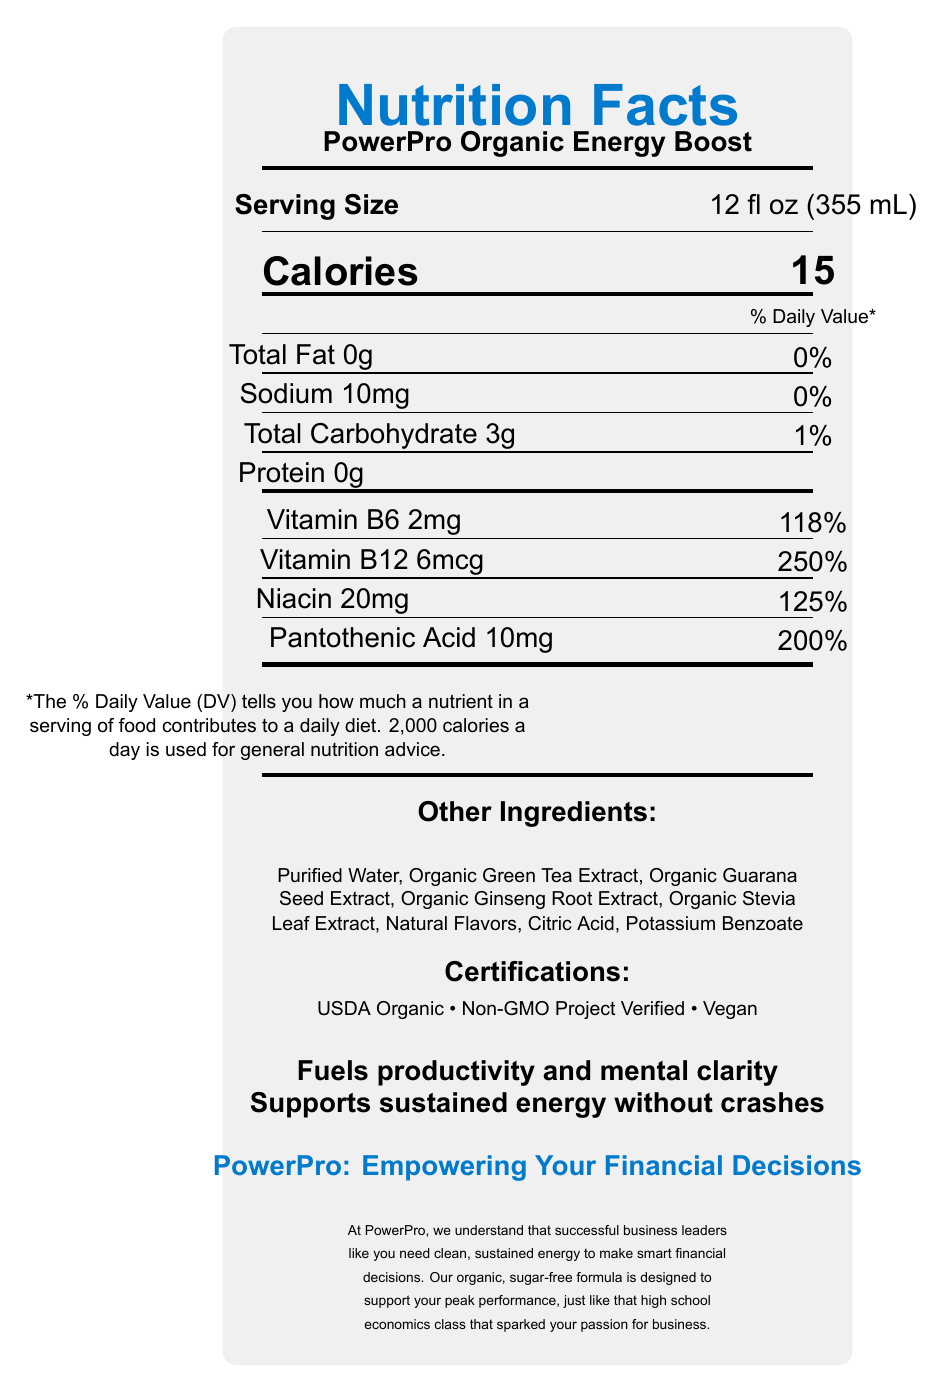what is the serving size of PowerPro Organic Energy Boost? The serving size is listed towards the top of the document under the heading "Serving Size".
Answer: 12 fl oz (355 mL) what is the amount of total fat per serving? The amount of total fat is mentioned under the section for nutrients, specifically stating "Total Fat 0g".
Answer: 0g How many calories are there in one serving of PowerPro Organic Energy Boost? The calorie content is displayed prominently in large font under the heading "Calories".
Answer: 15 What is the daily value percentage for Vitamin B12? The daily value percentage for Vitamin B12 is listed as 250%, found under the vitamins and minerals section.
Answer: 250% List any certifications mentioned for PowerPro Organic Energy Boost. The certifications are listed in the section titled "Certifications" towards the bottom of the document.
Answer: USDA Organic, Non-GMO Project Verified, Vegan Which ingredient in PowerPro Organic Energy Boost contributes to its caffeine content? This is inferred from common knowledge, as Guarana is known to contain caffeine, and it is listed in the ingredients section.
Answer: Organic Guarana Seed Extract What is the branding tagline at the bottom of the document? The tagline is found towards the bottom in a different color text, setting it apart from the rest of the document.
Answer: PowerPro: Empowering Your Financial Decisions How much sodium is there in one serving? The sodium content per serving is listed under the nutrients as "Sodium 10mg".
Answer: 10mg Is PowerPro Organic Energy Boost sugar-free? The product is labeled as sugar-free based on the marketing claims provided.
Answer: Yes What are the potential allergens mentioned in the document? The allergen information stated that the product is produced in a facility that also processes soy and tree nuts.
Answer: Soy and tree nuts What is the main idea of the document? The document presents nutritional details and appeals to health-conscious corporate leaders by emphasizing clean energy and mental clarity.
Answer: The document presents the Nutrition Facts Label for PowerPro Organic Energy Boost, highlighting its low-calorie content, high percentages of B vitamins, caffeine content, organic ingredients, certifications, and marketing claims aimed at business leaders seeking sustained energy and mental clarity without crashes. Identify how many elements are listed under "Other Ingredients". A. 5 B. 7 C. 8 D. 10 The document lists 8 ingredients under "Other Ingredients": Purified Water, Organic Green Tea Extract, Organic Guarana Seed Extract, Organic Ginseng Root Extract, Organic Stevia Leaf Extract, Natural Flavors, Citric Acid, and Potassium Benzoate.
Answer: C What percentage of daily value do the total carbohydrates in one serving contribute? A. 0% B. 1% C. 5% D. 10% The total carbohydrates contribute 1% to the daily value, as listed in the nutrient section.
Answer: B Does the product contain any artificial sweeteners? The document explicitly states in the marketing claims that there are no artificial sweeteners.
Answer: No What is the approximate caffeine content as compared to an average cup of coffee? The document lists the caffeine content but does not provide a comparison to the caffeine content of an average cup of coffee.
Answer: Cannot be determined What is the relationship between the product and financial decision-making according to the document? The company statement and tagline discuss the product's role in supporting peak performance and smart financial decisions, similar to the benefits of a high school economics class.
Answer: The document connects the consumption of PowerPro Organic Energy Boost with enhanced mental clarity and sustained energy, crucial for making smart financial decisions as a business leader. 